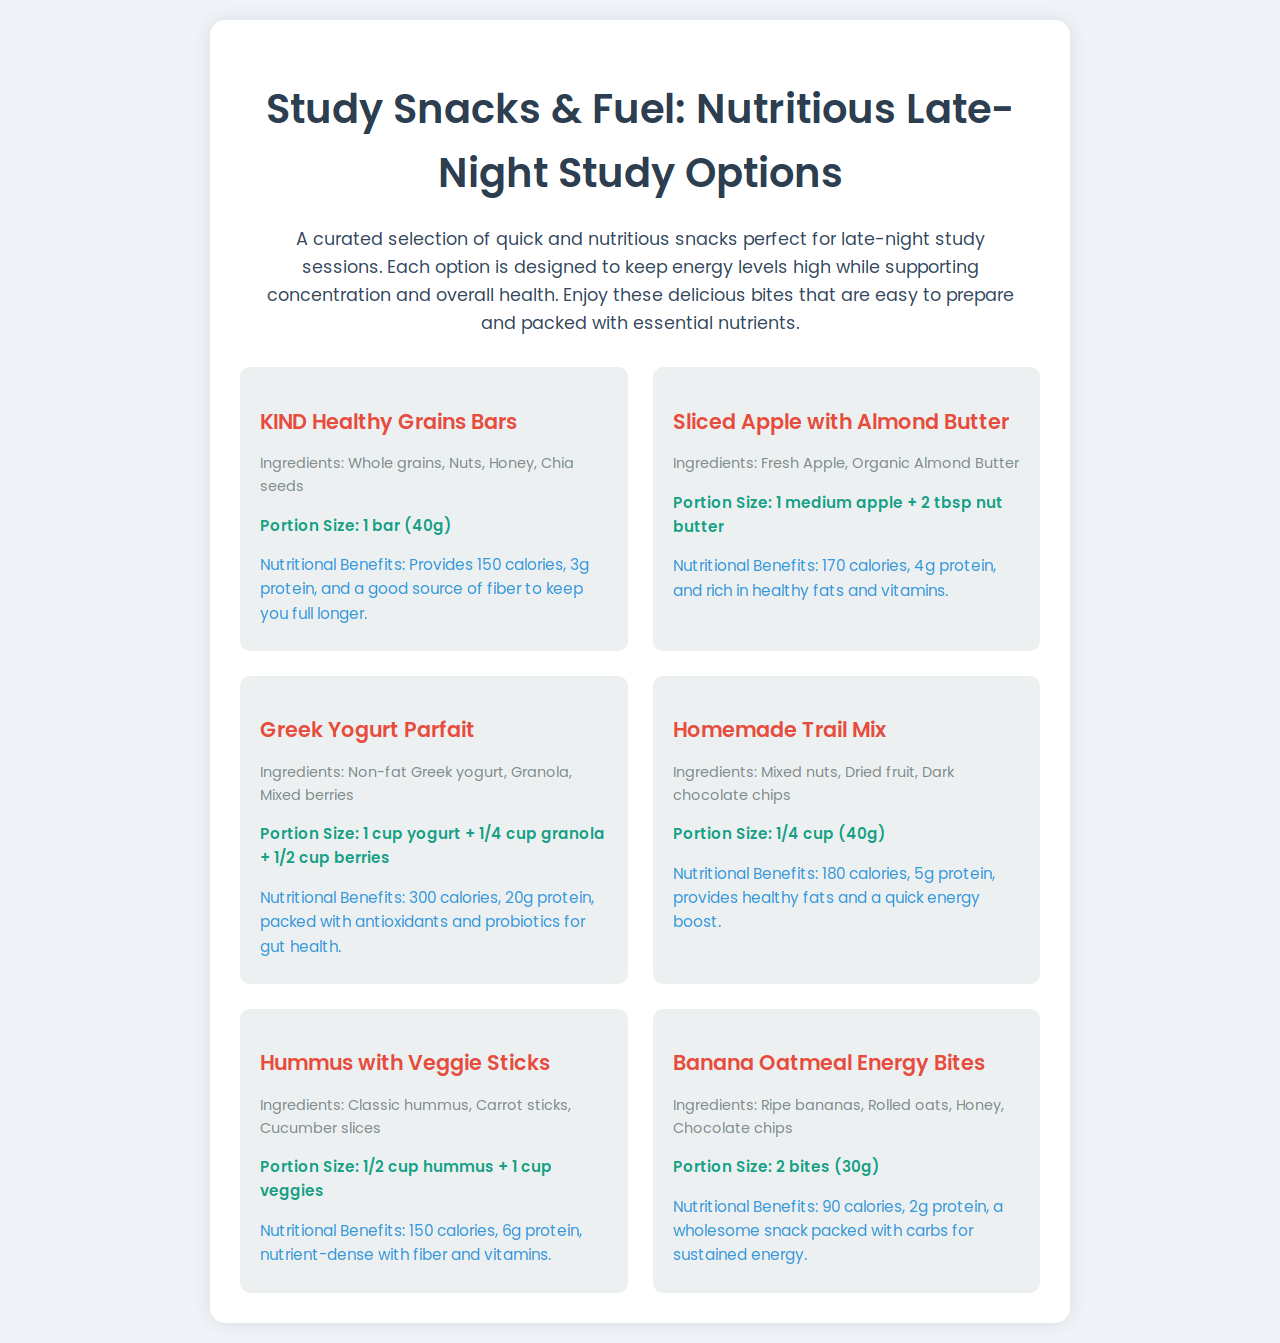What is the portion size for KIND Healthy Grains Bars? The portion size for KIND Healthy Grains Bars is mentioned in the document as 1 bar (40g).
Answer: 1 bar (40g) How many grams of protein does the Greek Yogurt Parfait provide? The Greek Yogurt Parfait provides 20g of protein, as specified in its nutritional benefits in the document.
Answer: 20g What ingredients are in the Sliced Apple with Almond Butter? The ingredients for Sliced Apple with Almond Butter include Fresh Apple and Organic Almond Butter, listed in the item description.
Answer: Fresh Apple, Organic Almond Butter Which snack has the highest calorie count? By comparing the nutritional benefits of all snacks, the Greek Yogurt Parfait has the highest calorie count with 300 calories.
Answer: 300 calories What are the ingredients of the Homemade Trail Mix? The ingredients in the Homemade Trail Mix are mixed nuts, dried fruit, and dark chocolate chips, explicitly mentioned in the item details.
Answer: Mixed nuts, Dried fruit, Dark chocolate chips How many calories does the Hummus with Veggie Sticks have? The document states that Hummus with Veggie Sticks contains 150 calories in its nutritional benefits section.
Answer: 150 calories What is the nutritional benefit of the Banana Oatmeal Energy Bites? The nutritional benefit of the Banana Oatmeal Energy Bites is a wholesome snack packed with carbs, providing 90 calories and 2g of protein.
Answer: 90 calories, 2g protein What type of snack is the Greek Yogurt Parfait categorized as? The Greek Yogurt Parfait is categorized as a parfait, as indicated by its name and ingredients in the document.
Answer: Parfait 